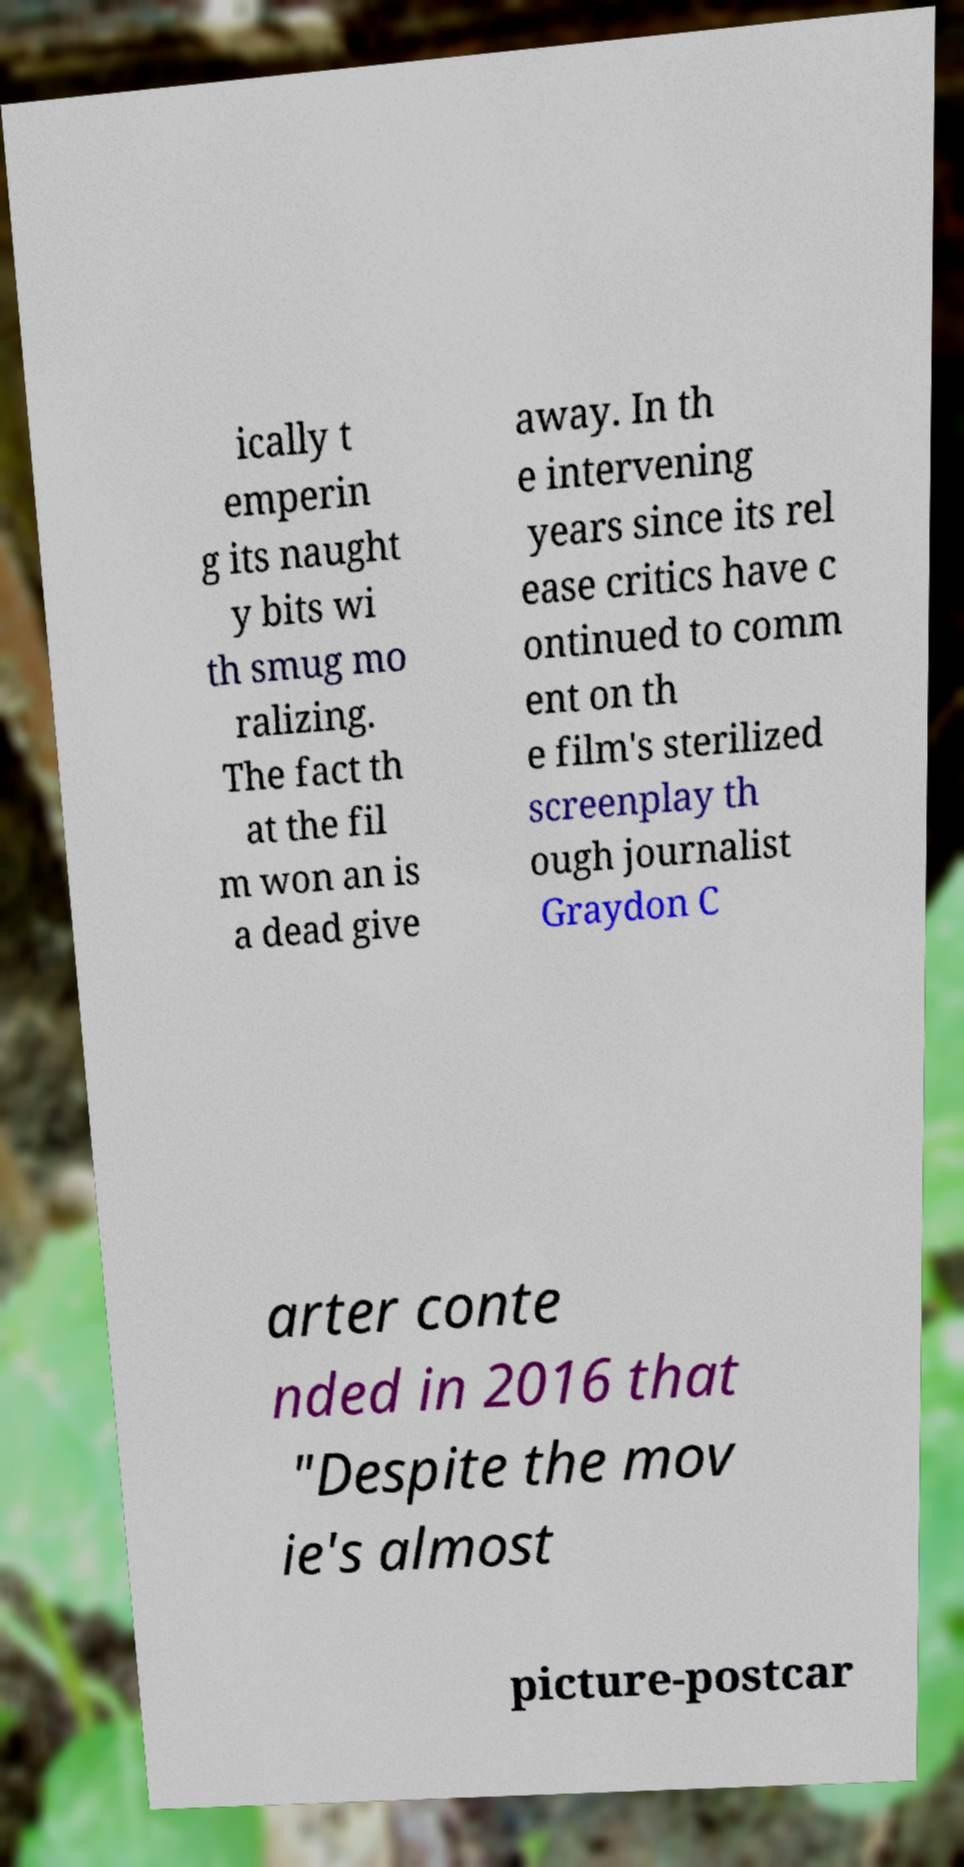There's text embedded in this image that I need extracted. Can you transcribe it verbatim? ically t emperin g its naught y bits wi th smug mo ralizing. The fact th at the fil m won an is a dead give away. In th e intervening years since its rel ease critics have c ontinued to comm ent on th e film's sterilized screenplay th ough journalist Graydon C arter conte nded in 2016 that "Despite the mov ie's almost picture-postcar 